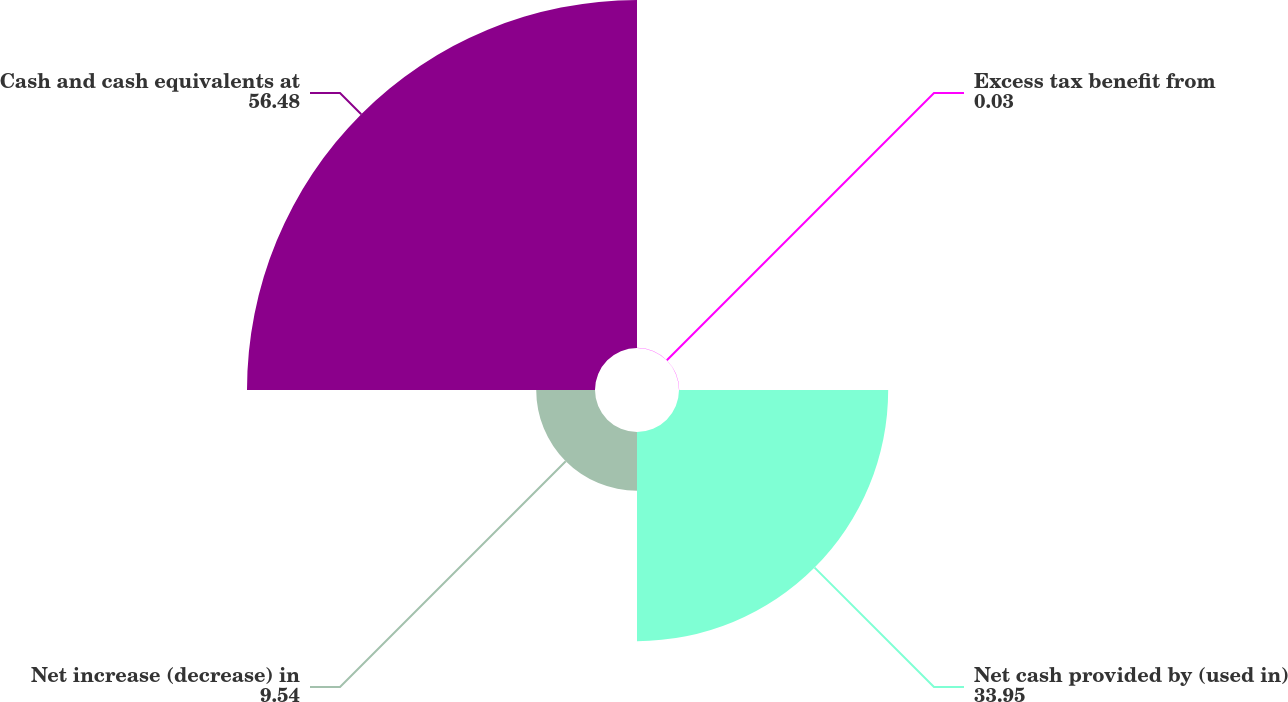Convert chart to OTSL. <chart><loc_0><loc_0><loc_500><loc_500><pie_chart><fcel>Excess tax benefit from<fcel>Net cash provided by (used in)<fcel>Net increase (decrease) in<fcel>Cash and cash equivalents at<nl><fcel>0.03%<fcel>33.95%<fcel>9.54%<fcel>56.48%<nl></chart> 